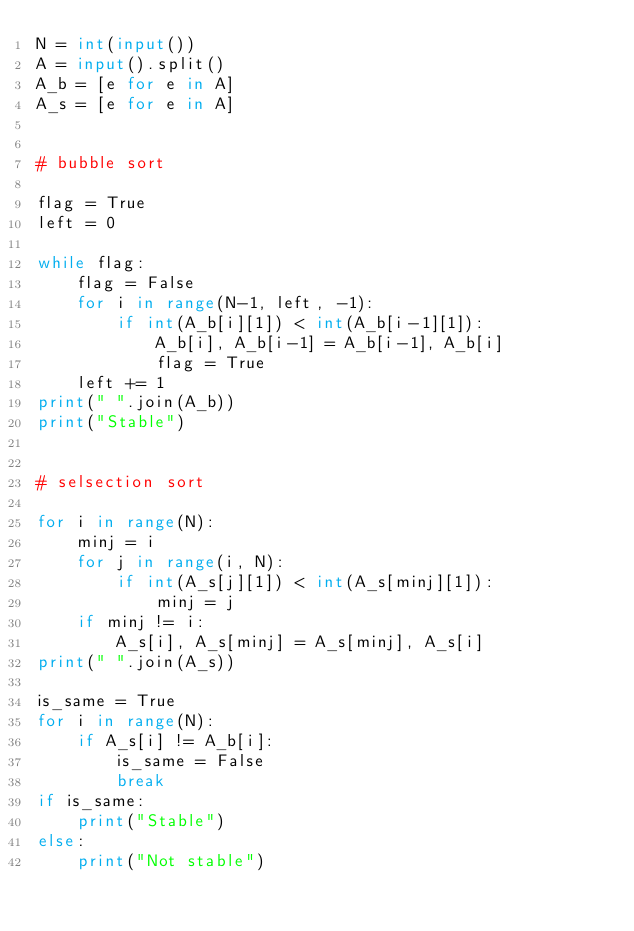Convert code to text. <code><loc_0><loc_0><loc_500><loc_500><_Python_>N = int(input())
A = input().split()
A_b = [e for e in A]
A_s = [e for e in A]


# bubble sort

flag = True
left = 0

while flag:
    flag = False
    for i in range(N-1, left, -1):
        if int(A_b[i][1]) < int(A_b[i-1][1]):
            A_b[i], A_b[i-1] = A_b[i-1], A_b[i]
            flag = True
    left += 1
print(" ".join(A_b))
print("Stable")


# selsection sort

for i in range(N):
    minj = i
    for j in range(i, N):
        if int(A_s[j][1]) < int(A_s[minj][1]):
            minj = j
    if minj != i:
        A_s[i], A_s[minj] = A_s[minj], A_s[i]
print(" ".join(A_s))

is_same = True
for i in range(N):
    if A_s[i] != A_b[i]:
        is_same = False
        break
if is_same:
    print("Stable")
else:
    print("Not stable")

</code> 